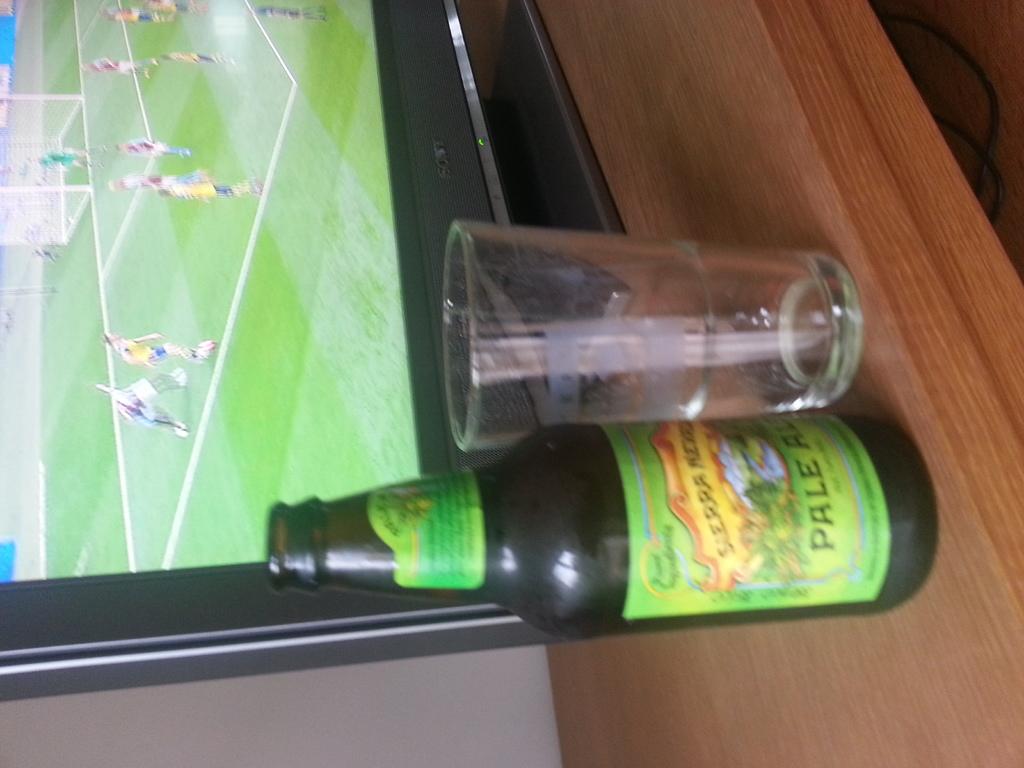What kind of beer is this?
Your answer should be compact. Pale ale. 